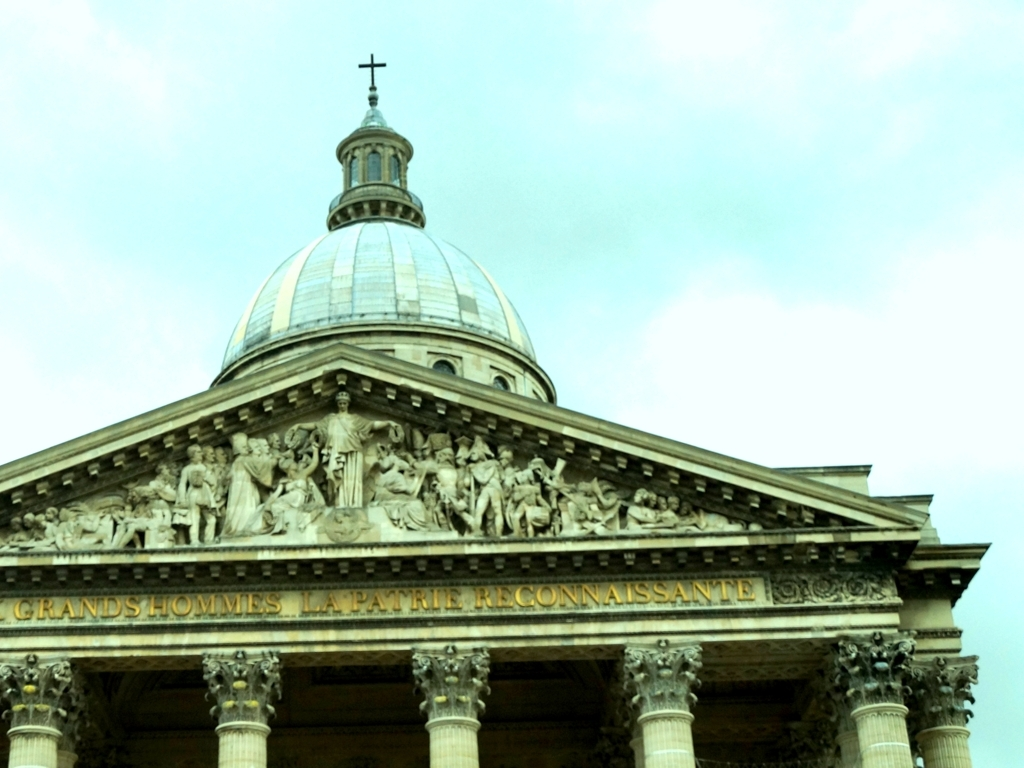What does the inscription on the building mean? The inscription 'AUX GRANDS HOMMES LA PATRIE RECONNAISSANTE' translates to 'To the great men, the grateful fatherland.' It is a tribute to notable individuals who have contributed significantly to the nation's legacy. Is this a common feature on such buildings? Inscriptions like this are common on monumental architecture, particularly those erected in honor of important historical figures or events. They serve as a form of public recognition and collective memory. 